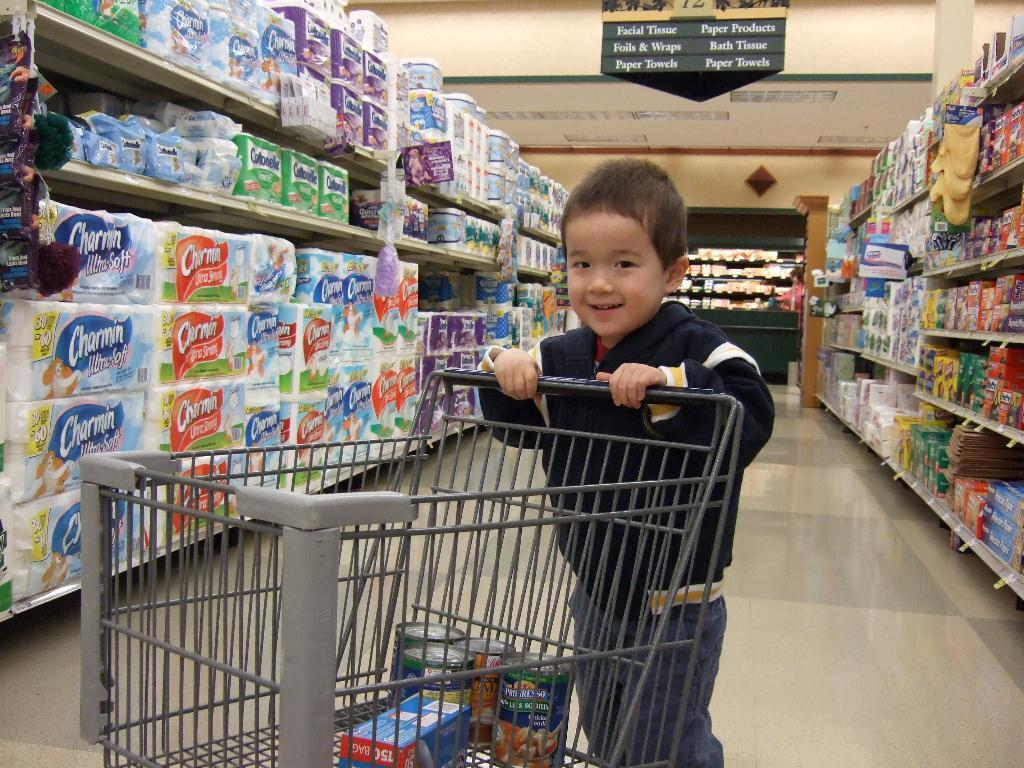<image>
Summarize the visual content of the image. A boy pushes a cart in the Facial Tissue aisle. 